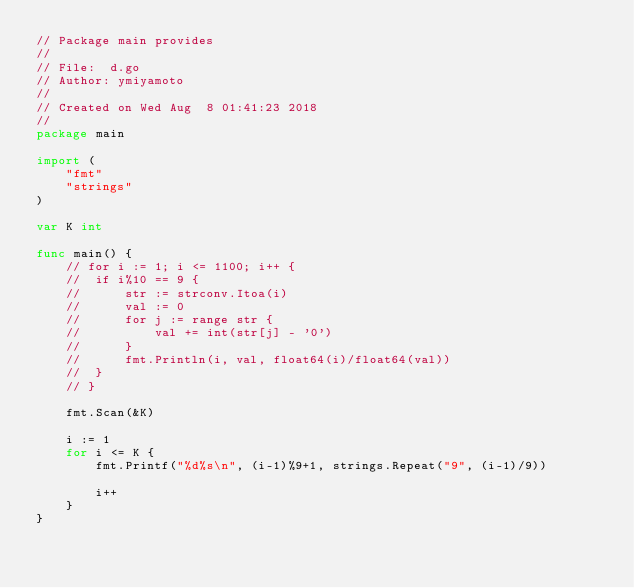Convert code to text. <code><loc_0><loc_0><loc_500><loc_500><_Go_>// Package main provides
//
// File:  d.go
// Author: ymiyamoto
//
// Created on Wed Aug  8 01:41:23 2018
//
package main

import (
	"fmt"
	"strings"
)

var K int

func main() {
	// for i := 1; i <= 1100; i++ {
	// 	if i%10 == 9 {
	// 		str := strconv.Itoa(i)
	// 		val := 0
	// 		for j := range str {
	// 			val += int(str[j] - '0')
	// 		}
	// 		fmt.Println(i, val, float64(i)/float64(val))
	// 	}
	// }

	fmt.Scan(&K)

	i := 1
	for i <= K {
		fmt.Printf("%d%s\n", (i-1)%9+1, strings.Repeat("9", (i-1)/9))

		i++
	}
}
</code> 